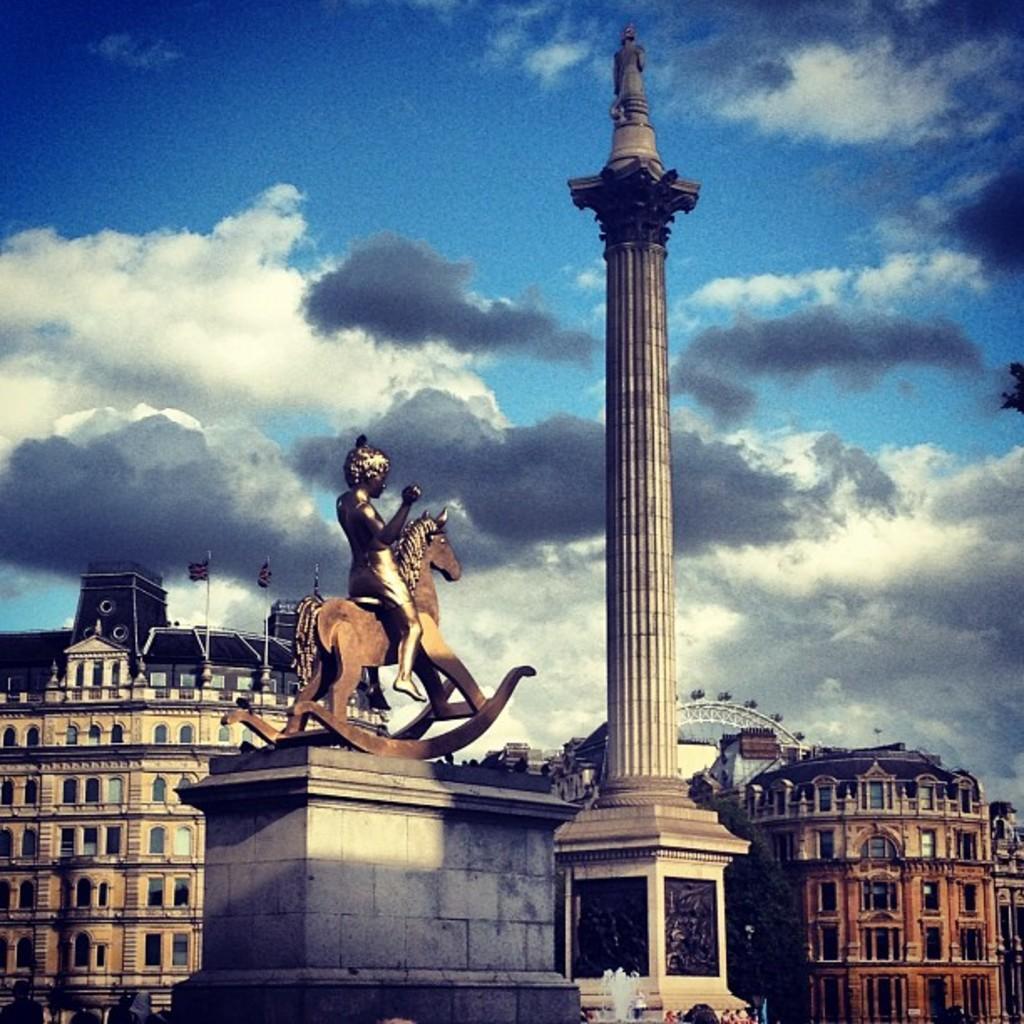Can you describe this image briefly? In this image we can see the statue, some buildings with windows, the flags, fountain, a roller coaster and the tower. On the backside we can see the sky which looks cloudy. 